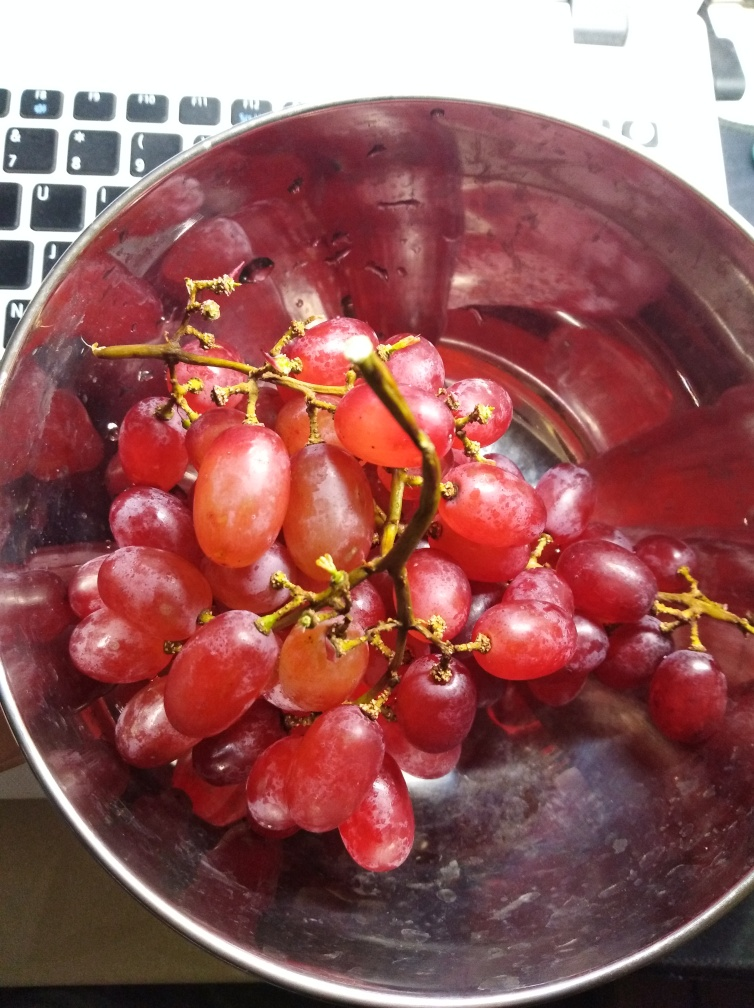What do the colors in the image suggest about the freshness of the grapes? The rich purple and red hues of the grapes suggest they are ripe and fresh, ready to be enjoyed. The vibrant colors typically indicate that the fruit is at peak ripeness, which often correlates with optimal flavor and texture. 